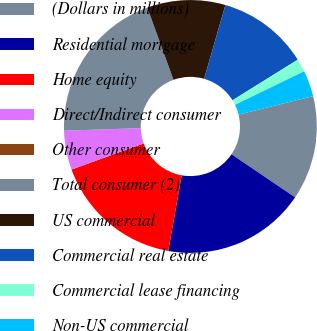<chart> <loc_0><loc_0><loc_500><loc_500><pie_chart><fcel>(Dollars in millions)<fcel>Residential mortgage<fcel>Home equity<fcel>Direct/Indirect consumer<fcel>Other consumer<fcel>Total consumer (2)<fcel>US commercial<fcel>Commercial real estate<fcel>Commercial lease financing<fcel>Non-US commercial<nl><fcel>13.33%<fcel>18.33%<fcel>16.67%<fcel>5.0%<fcel>0.0%<fcel>20.0%<fcel>10.0%<fcel>11.67%<fcel>1.67%<fcel>3.33%<nl></chart> 